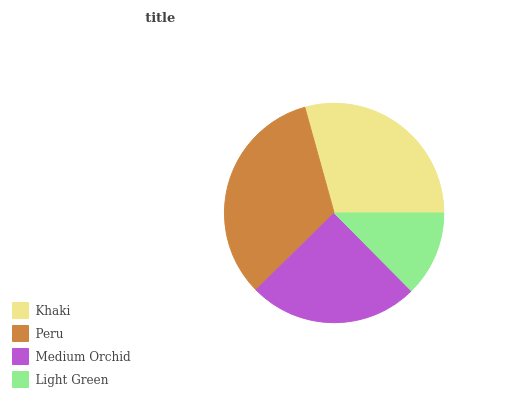Is Light Green the minimum?
Answer yes or no. Yes. Is Peru the maximum?
Answer yes or no. Yes. Is Medium Orchid the minimum?
Answer yes or no. No. Is Medium Orchid the maximum?
Answer yes or no. No. Is Peru greater than Medium Orchid?
Answer yes or no. Yes. Is Medium Orchid less than Peru?
Answer yes or no. Yes. Is Medium Orchid greater than Peru?
Answer yes or no. No. Is Peru less than Medium Orchid?
Answer yes or no. No. Is Khaki the high median?
Answer yes or no. Yes. Is Medium Orchid the low median?
Answer yes or no. Yes. Is Peru the high median?
Answer yes or no. No. Is Peru the low median?
Answer yes or no. No. 